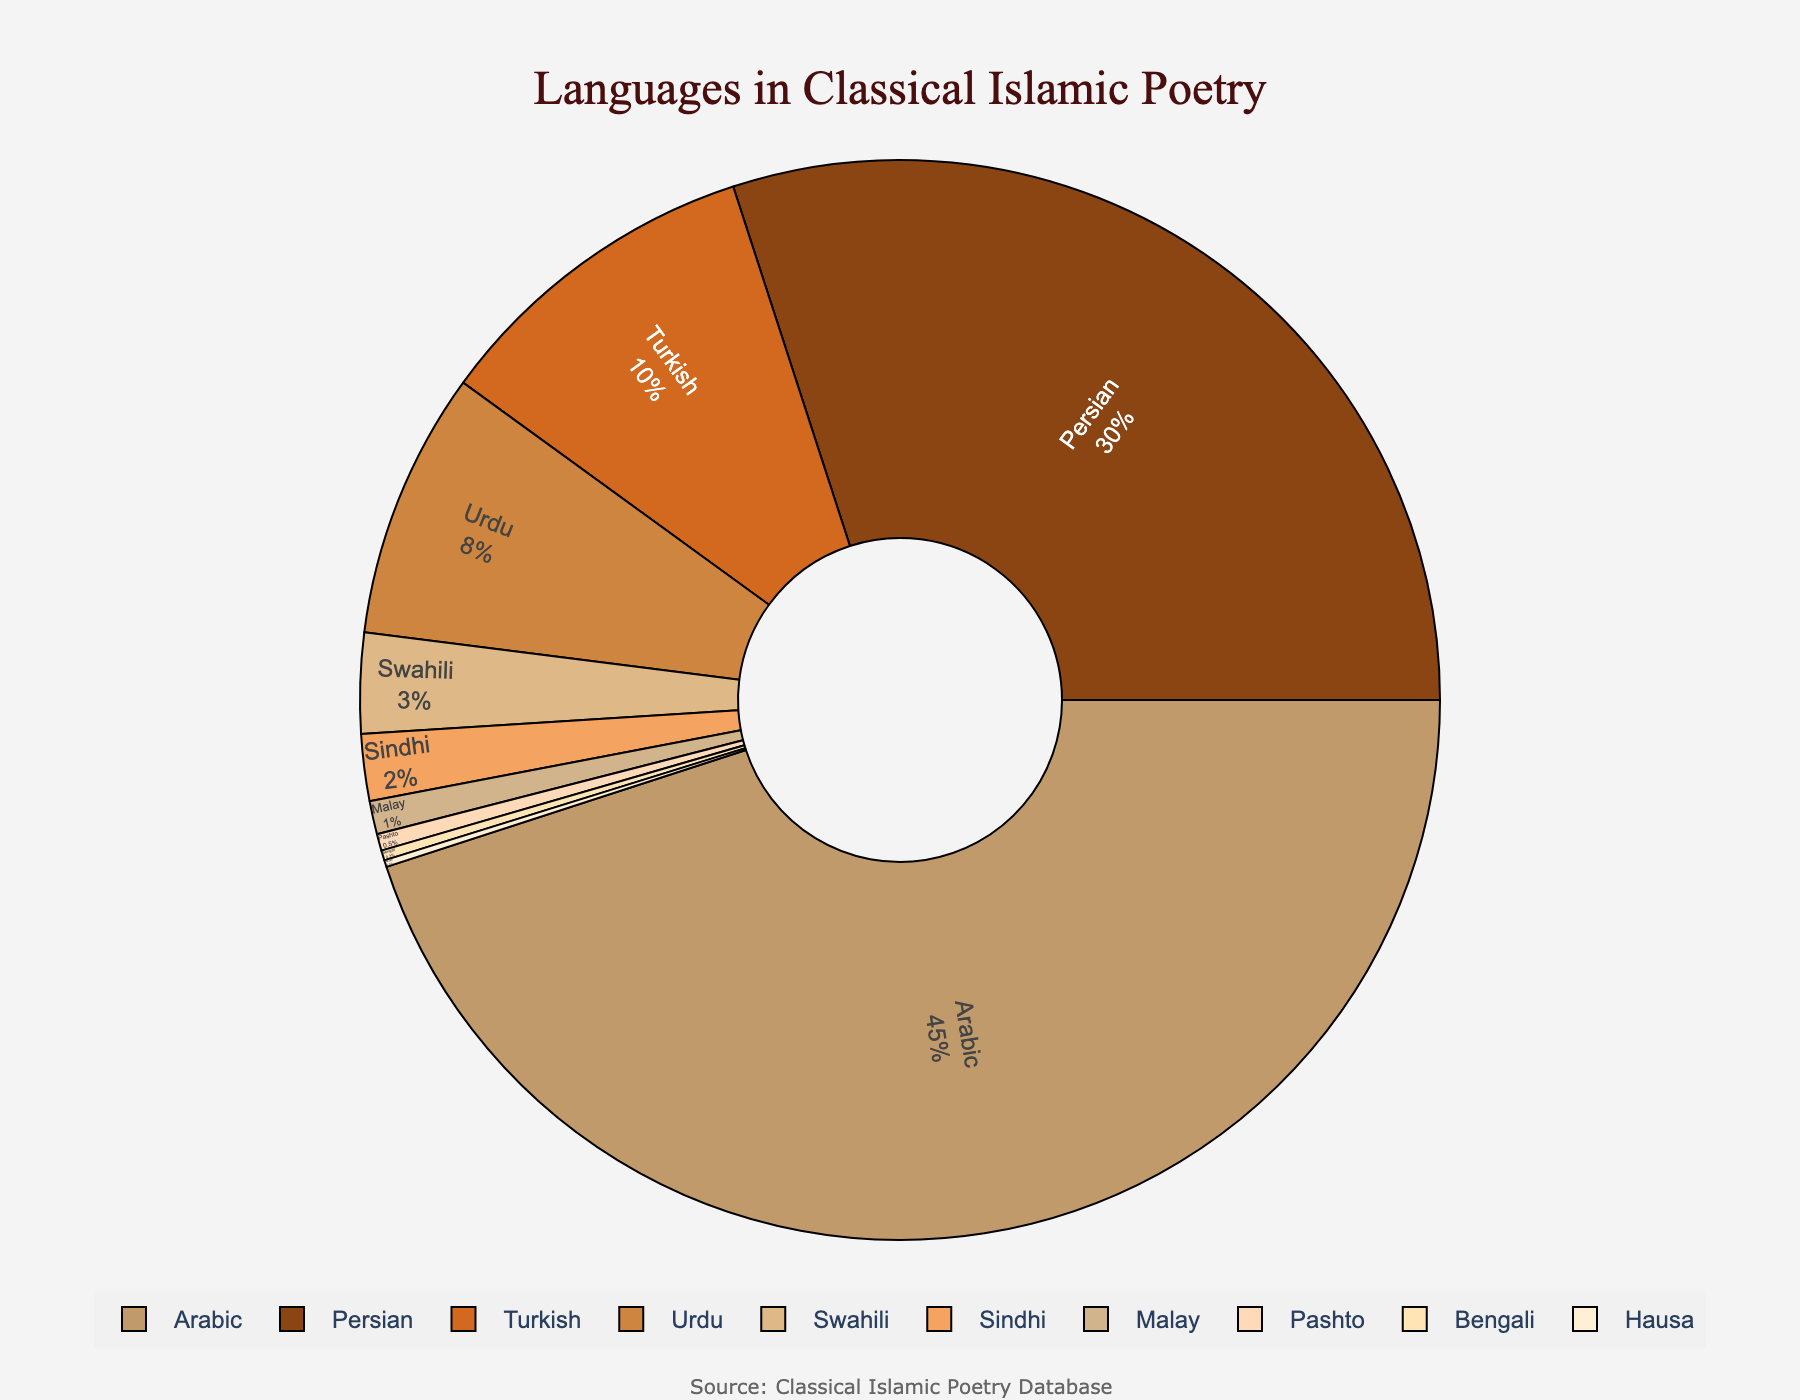What percentage of classical Islamic poetry is in Arabic? The pie chart shows the percentage breakdown of languages used in classical Islamic poetry. Locate the section for Arabic and read the corresponding percentage.
Answer: 45% Which two languages together make up more than 50% of the classical Islamic poetry? Identify the two largest sections in the pie chart. Arabic is 45% and Persian is 30%. Summing them gives 45% + 30% = 75%, which is more than 50%.
Answer: Arabic and Persian How does the use of Turkish compare to Urdu in classical Islamic poetry? Locate the sections for Turkish and Urdu in the pie chart. Turkish is at 10%, while Urdu is at 8%. Compare these two percentages.
Answer: Turkish is more than Urdu What is the difference in percentage points between the usage of Swahili and Sindhi? Find the segments for Swahili and Sindhi. Swahili is 3% and Sindhi is 2%. Calculate the difference: 3% - 2% = 1%.
Answer: 1% What are the percentages for all languages that individually contribute less than 5% to classical Islamic poetry? Locate the segments in the pie chart where the percentage is less than 5%. These are Turkish (10%), Urdu (8%), Swahili (3%), Sindhi (2%), Malay (1%), Pashto (0.5%), Bengali (0.3%), and Hausa (0.2%). Summarize their percentages.
Answer: 24% How does the combined percentage of Malay, Pashto, Bengali, and Hausa compare to the percentage of Turkish? Find the segments for Malay, Pashto, Bengali, and Hausa. Their percentages are 1%, 0.5%, 0.3%, and 0.2%, respectively. Sum these: 1% + 0.5% + 0.3% + 0.2% = 2%. Compare this combined percentage with Turkish, which is 10%.
Answer: Turkish is higher What percentage of classical Islamic poetry is represented by languages other than Arabic and Persian? Sum all language percentages and subtract the combined percentages of Arabic (45%) and Persian (30%). The total is 100%, so: 100% - (45% + 30%) = 100% - 75% = 25%.
Answer: 25% Which language has the smallest representation in classical Islamic poetry? Identify the smallest segment in the pie chart. Bengali has the smallest percentage at 0.2%.
Answer: Hausa 